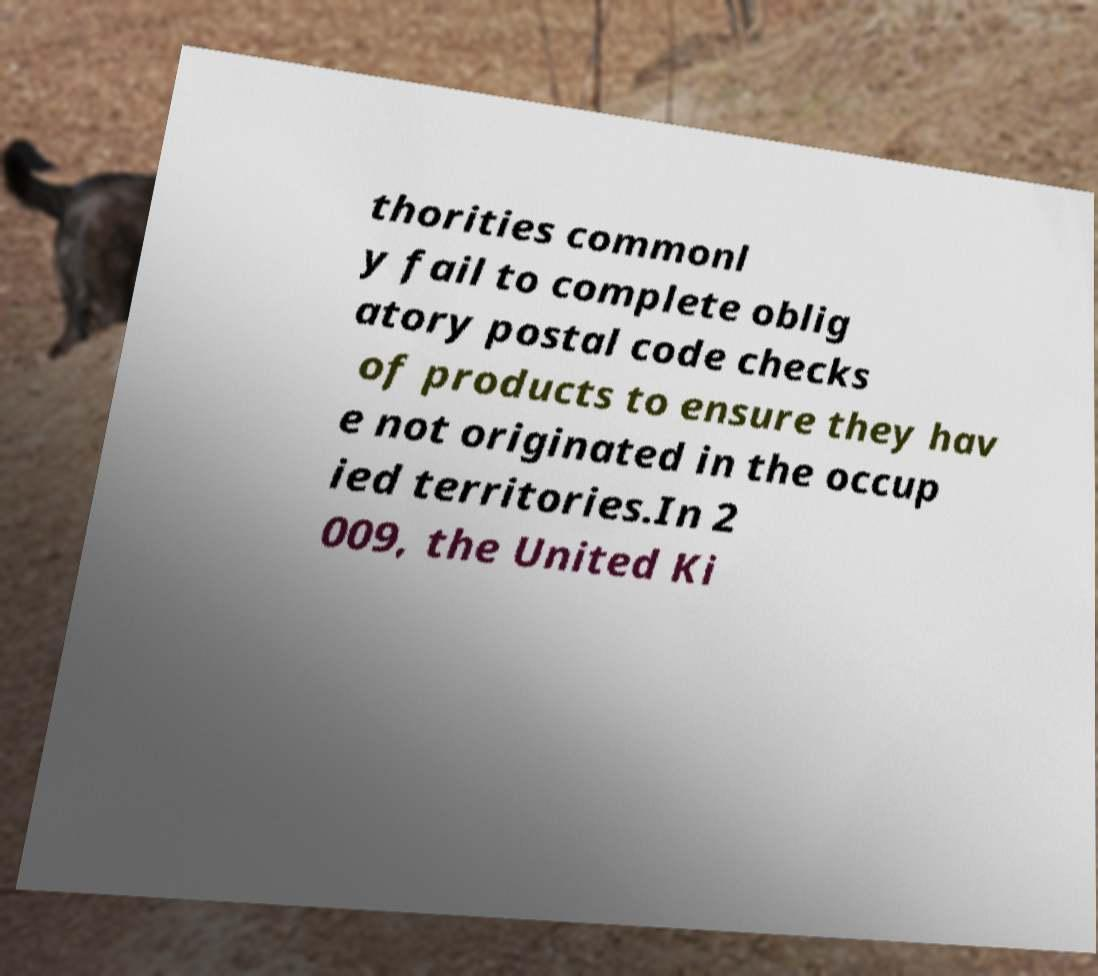There's text embedded in this image that I need extracted. Can you transcribe it verbatim? thorities commonl y fail to complete oblig atory postal code checks of products to ensure they hav e not originated in the occup ied territories.In 2 009, the United Ki 